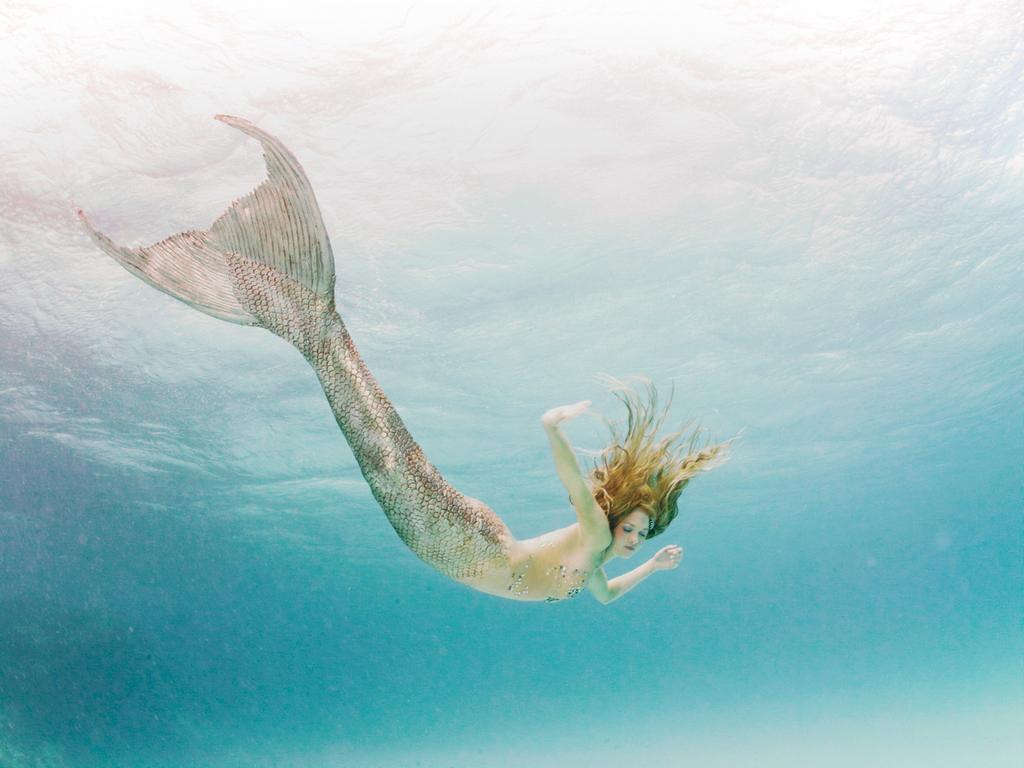Could you give a brief overview of what you see in this image? In this image I can see the mermaid in the water. I can see the water is in blue color. 